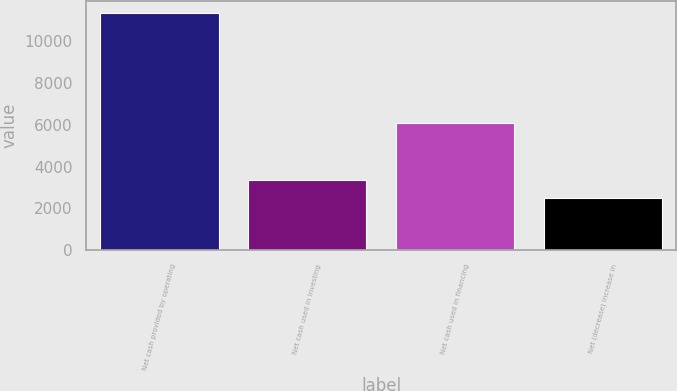<chart> <loc_0><loc_0><loc_500><loc_500><bar_chart><fcel>Net cash provided by operating<fcel>Net cash used in investing<fcel>Net cash used in financing<fcel>Net (decrease) increase in<nl><fcel>11353<fcel>3375.4<fcel>6077<fcel>2489<nl></chart> 